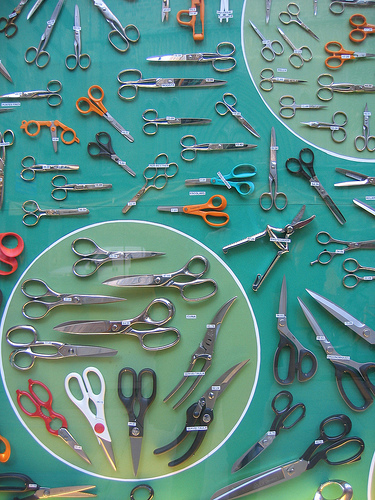Are there staplers or chairs in this photo? There are neither staplers nor chairs visible in this photo. 